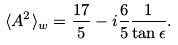Convert formula to latex. <formula><loc_0><loc_0><loc_500><loc_500>\langle A ^ { 2 } \rangle _ { w } = \frac { 1 7 } { 5 } - i \frac { 6 } { 5 } \frac { 1 } { \tan \epsilon } .</formula> 